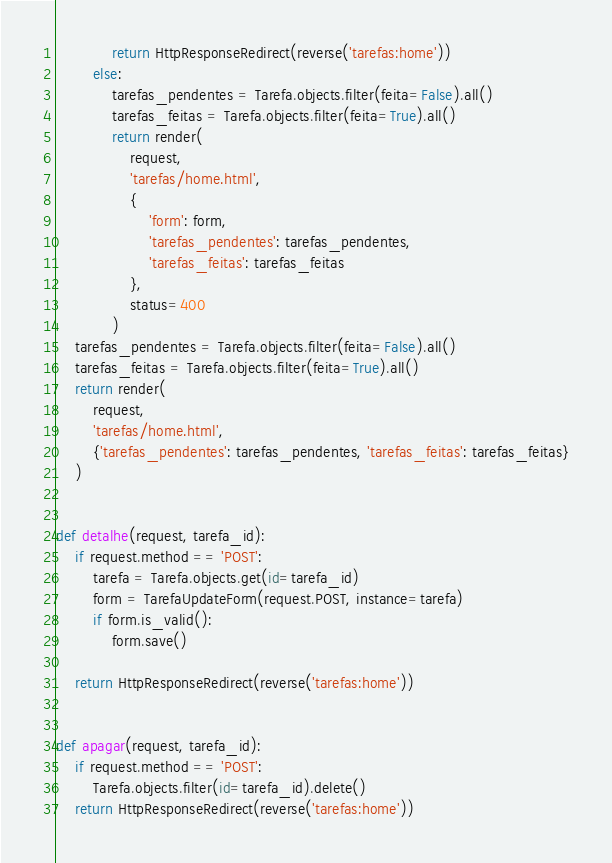<code> <loc_0><loc_0><loc_500><loc_500><_Python_>            return HttpResponseRedirect(reverse('tarefas:home'))
        else:
            tarefas_pendentes = Tarefa.objects.filter(feita=False).all()
            tarefas_feitas = Tarefa.objects.filter(feita=True).all()
            return render(
                request,
                'tarefas/home.html',
                {
                    'form': form,
                    'tarefas_pendentes': tarefas_pendentes,
                    'tarefas_feitas': tarefas_feitas
                },
                status=400
            )
    tarefas_pendentes = Tarefa.objects.filter(feita=False).all()
    tarefas_feitas = Tarefa.objects.filter(feita=True).all()
    return render(
        request,
        'tarefas/home.html',
        {'tarefas_pendentes': tarefas_pendentes, 'tarefas_feitas': tarefas_feitas}
    )


def detalhe(request, tarefa_id):
    if request.method == 'POST':
        tarefa = Tarefa.objects.get(id=tarefa_id)
        form = TarefaUpdateForm(request.POST, instance=tarefa)
        if form.is_valid():
            form.save()

    return HttpResponseRedirect(reverse('tarefas:home'))


def apagar(request, tarefa_id):
    if request.method == 'POST':
        Tarefa.objects.filter(id=tarefa_id).delete()
    return HttpResponseRedirect(reverse('tarefas:home'))
</code> 